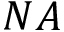Convert formula to latex. <formula><loc_0><loc_0><loc_500><loc_500>N A</formula> 